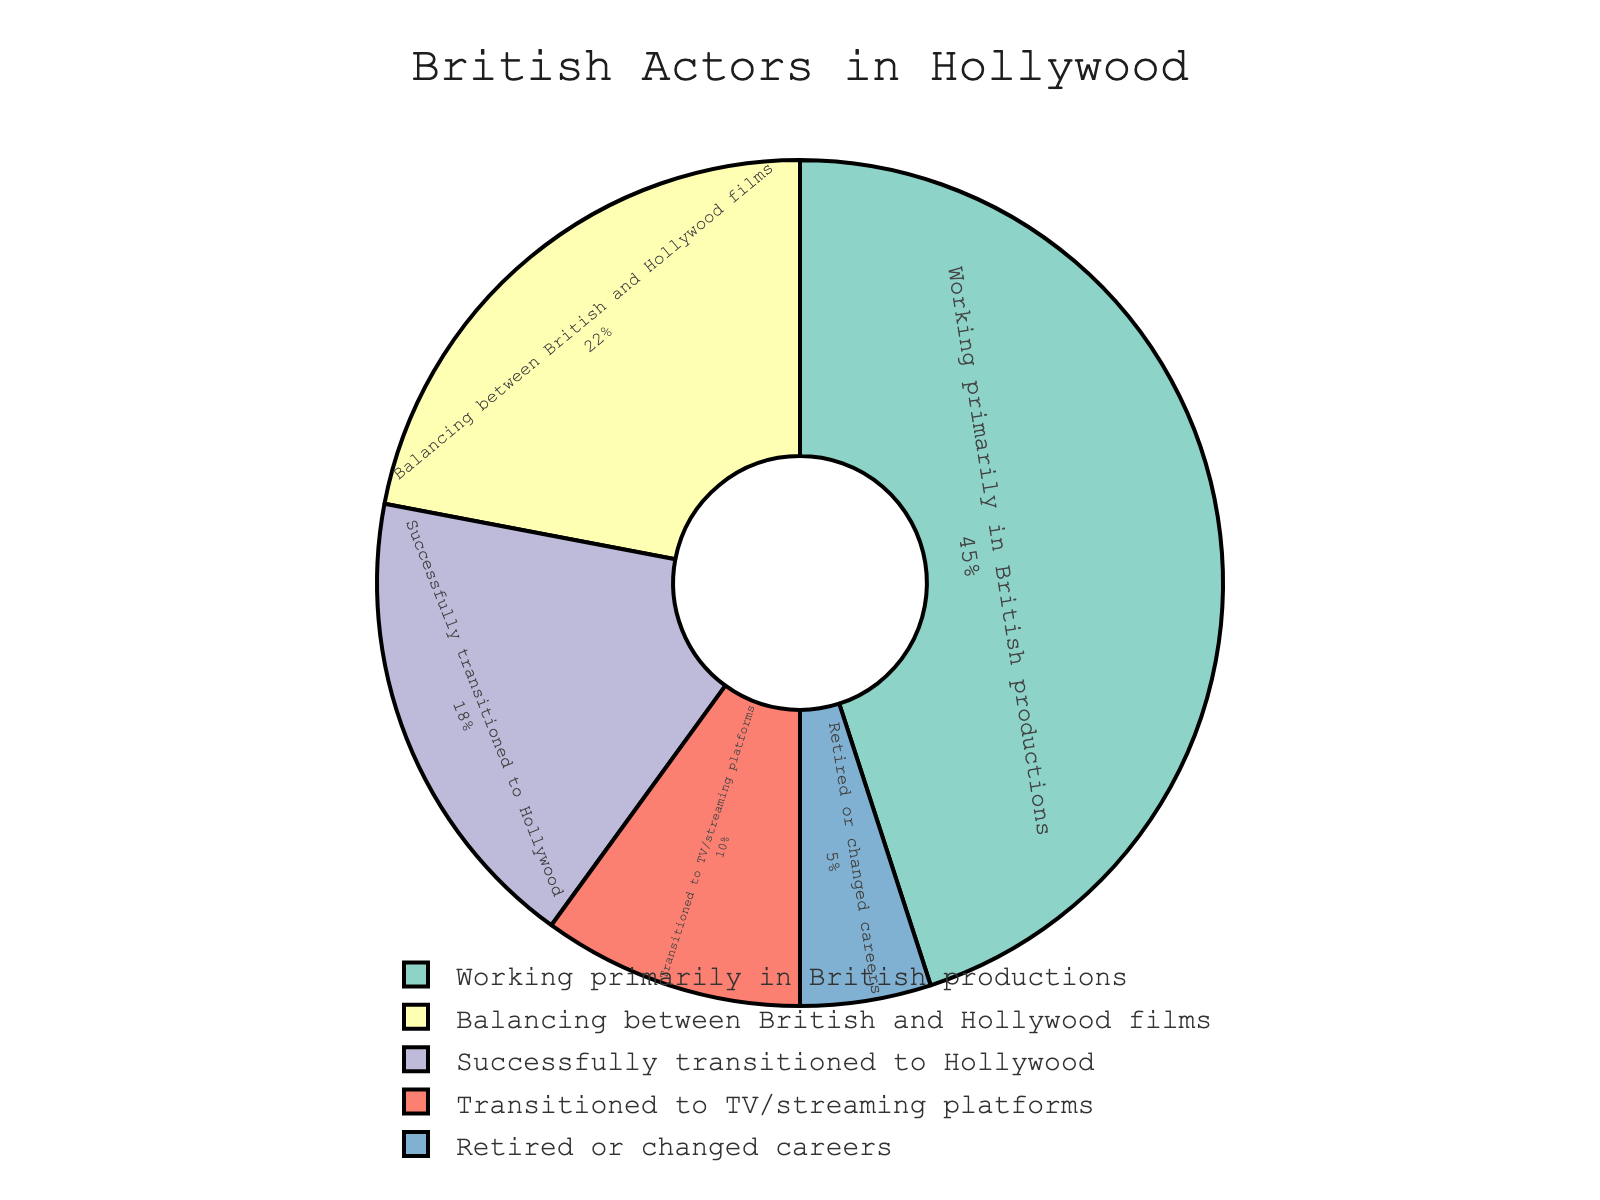What percentage of British actors are balancing between British and Hollywood films? To find the percentage of actors balancing between British and Hollywood films, locate the section of the pie chart labeled "Balancing between British and Hollywood films" and identify the percentage value.
Answer: 22% Which category has the largest proportion of British actors? To determine the category with the largest proportion, compare the sizes of the pie chart sections and find the one that is largest. The category "Working primarily in British productions" has the largest section.
Answer: Working primarily in British productions What is the total percentage of British actors who have either successfully transitioned to Hollywood or are balancing between British and Hollywood films? Add the percentages from the categories "Successfully transitioned to Hollywood" and "Balancing between British and Hollywood films". The values are 18% and 22% respectively. 18% + 22% = 40%.
Answer: 40% How many categories have percentages greater than 20%? Examine the pie chart and identify the sections with percentages over 20%. There are two such categories: "Working primarily in British productions" (45%) and "Balancing between British and Hollywood films" (22%).
Answer: 2 Is the proportion of British actors who have retired or changed careers higher or lower than those who have transitioned to TV/streaming platforms? Compare the percentages of the "Retired or changed careers" category (5%) and the "Transitioned to TV/streaming platforms" category (10%). 5% is lower than 10%.
Answer: Lower What's the percentage difference between British actors working primarily in British productions and those who successfully transitioned to Hollywood? Subtract the percentage of "Successfully transitioned to Hollywood" (18%) from the "Working primarily in British productions" (45%). 45% - 18% = 27%.
Answer: 27% What is the combined percentage of British actors who either work primarily in British productions or transitioned to TV/streaming platforms? Add the percentages from the categories "Working primarily in British productions" (45%) and "Transitioned to TV/streaming platforms" (10%). 45% + 10% = 55%.
Answer: 55% 